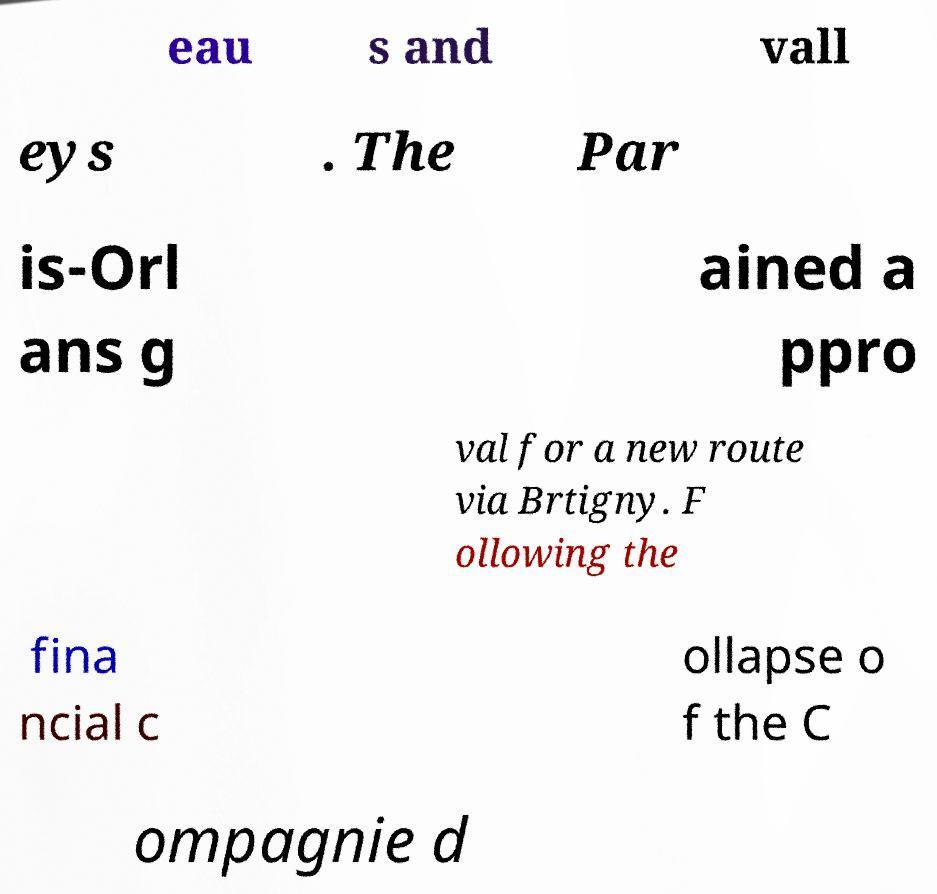For documentation purposes, I need the text within this image transcribed. Could you provide that? eau s and vall eys . The Par is-Orl ans g ained a ppro val for a new route via Brtigny. F ollowing the fina ncial c ollapse o f the C ompagnie d 